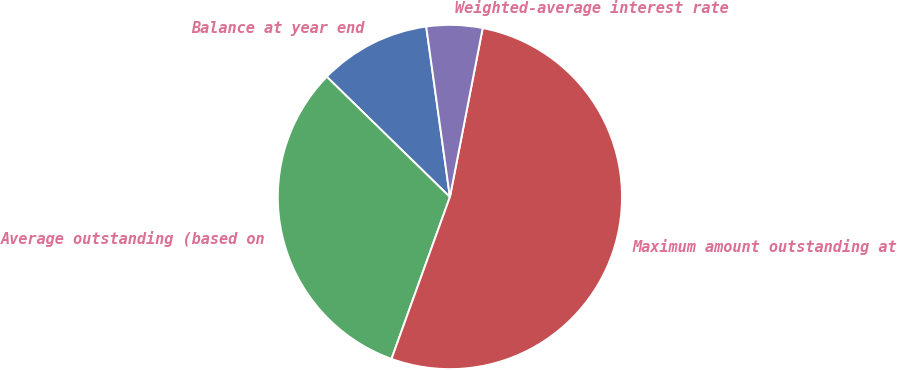Convert chart. <chart><loc_0><loc_0><loc_500><loc_500><pie_chart><fcel>Balance at year end<fcel>Average outstanding (based on<fcel>Maximum amount outstanding at<fcel>Weighted-average interest rate<nl><fcel>10.49%<fcel>31.8%<fcel>52.46%<fcel>5.25%<nl></chart> 